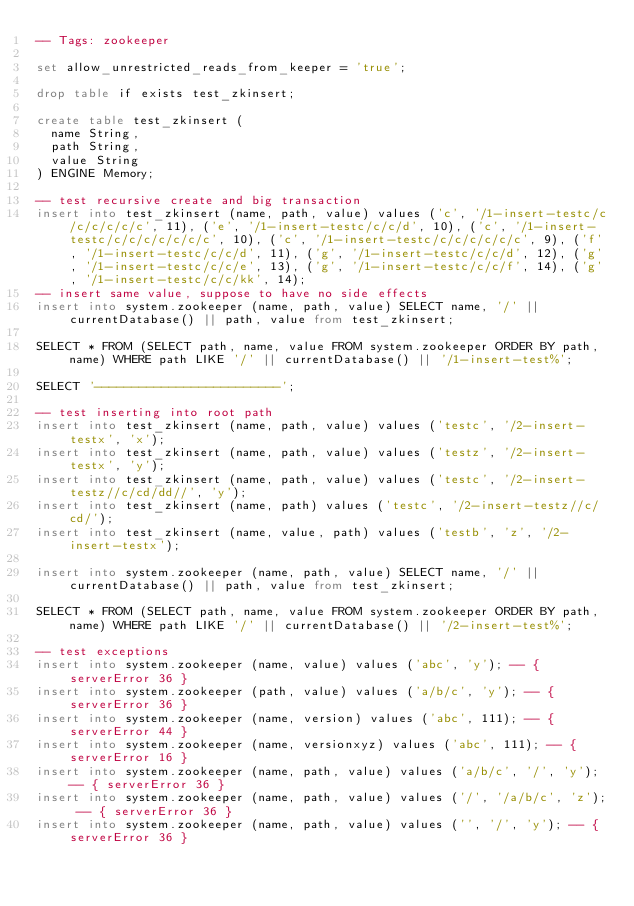Convert code to text. <code><loc_0><loc_0><loc_500><loc_500><_SQL_>-- Tags: zookeeper

set allow_unrestricted_reads_from_keeper = 'true';

drop table if exists test_zkinsert;

create table test_zkinsert (
	name String,
	path String,
	value String
) ENGINE Memory;

-- test recursive create and big transaction
insert into test_zkinsert (name, path, value) values ('c', '/1-insert-testc/c/c/c/c/c/c', 11), ('e', '/1-insert-testc/c/c/d', 10), ('c', '/1-insert-testc/c/c/c/c/c/c/c', 10), ('c', '/1-insert-testc/c/c/c/c/c/c', 9), ('f', '/1-insert-testc/c/c/d', 11), ('g', '/1-insert-testc/c/c/d', 12), ('g', '/1-insert-testc/c/c/e', 13), ('g', '/1-insert-testc/c/c/f', 14), ('g', '/1-insert-testc/c/c/kk', 14);
-- insert same value, suppose to have no side effects
insert into system.zookeeper (name, path, value) SELECT name, '/' || currentDatabase() || path, value from test_zkinsert;

SELECT * FROM (SELECT path, name, value FROM system.zookeeper ORDER BY path, name) WHERE path LIKE '/' || currentDatabase() || '/1-insert-test%';

SELECT '-------------------------';

-- test inserting into root path
insert into test_zkinsert (name, path, value) values ('testc', '/2-insert-testx', 'x');
insert into test_zkinsert (name, path, value) values ('testz', '/2-insert-testx', 'y');
insert into test_zkinsert (name, path, value) values ('testc', '/2-insert-testz//c/cd/dd//', 'y');
insert into test_zkinsert (name, path) values ('testc', '/2-insert-testz//c/cd/');
insert into test_zkinsert (name, value, path) values ('testb', 'z', '/2-insert-testx');

insert into system.zookeeper (name, path, value) SELECT name, '/' || currentDatabase() || path, value from test_zkinsert;

SELECT * FROM (SELECT path, name, value FROM system.zookeeper ORDER BY path, name) WHERE path LIKE '/' || currentDatabase() || '/2-insert-test%';

-- test exceptions 
insert into system.zookeeper (name, value) values ('abc', 'y'); -- { serverError 36 }
insert into system.zookeeper (path, value) values ('a/b/c', 'y'); -- { serverError 36 }
insert into system.zookeeper (name, version) values ('abc', 111); -- { serverError 44 }
insert into system.zookeeper (name, versionxyz) values ('abc', 111); -- { serverError 16 }
insert into system.zookeeper (name, path, value) values ('a/b/c', '/', 'y'); -- { serverError 36 }
insert into system.zookeeper (name, path, value) values ('/', '/a/b/c', 'z'); -- { serverError 36 }
insert into system.zookeeper (name, path, value) values ('', '/', 'y'); -- { serverError 36 }</code> 